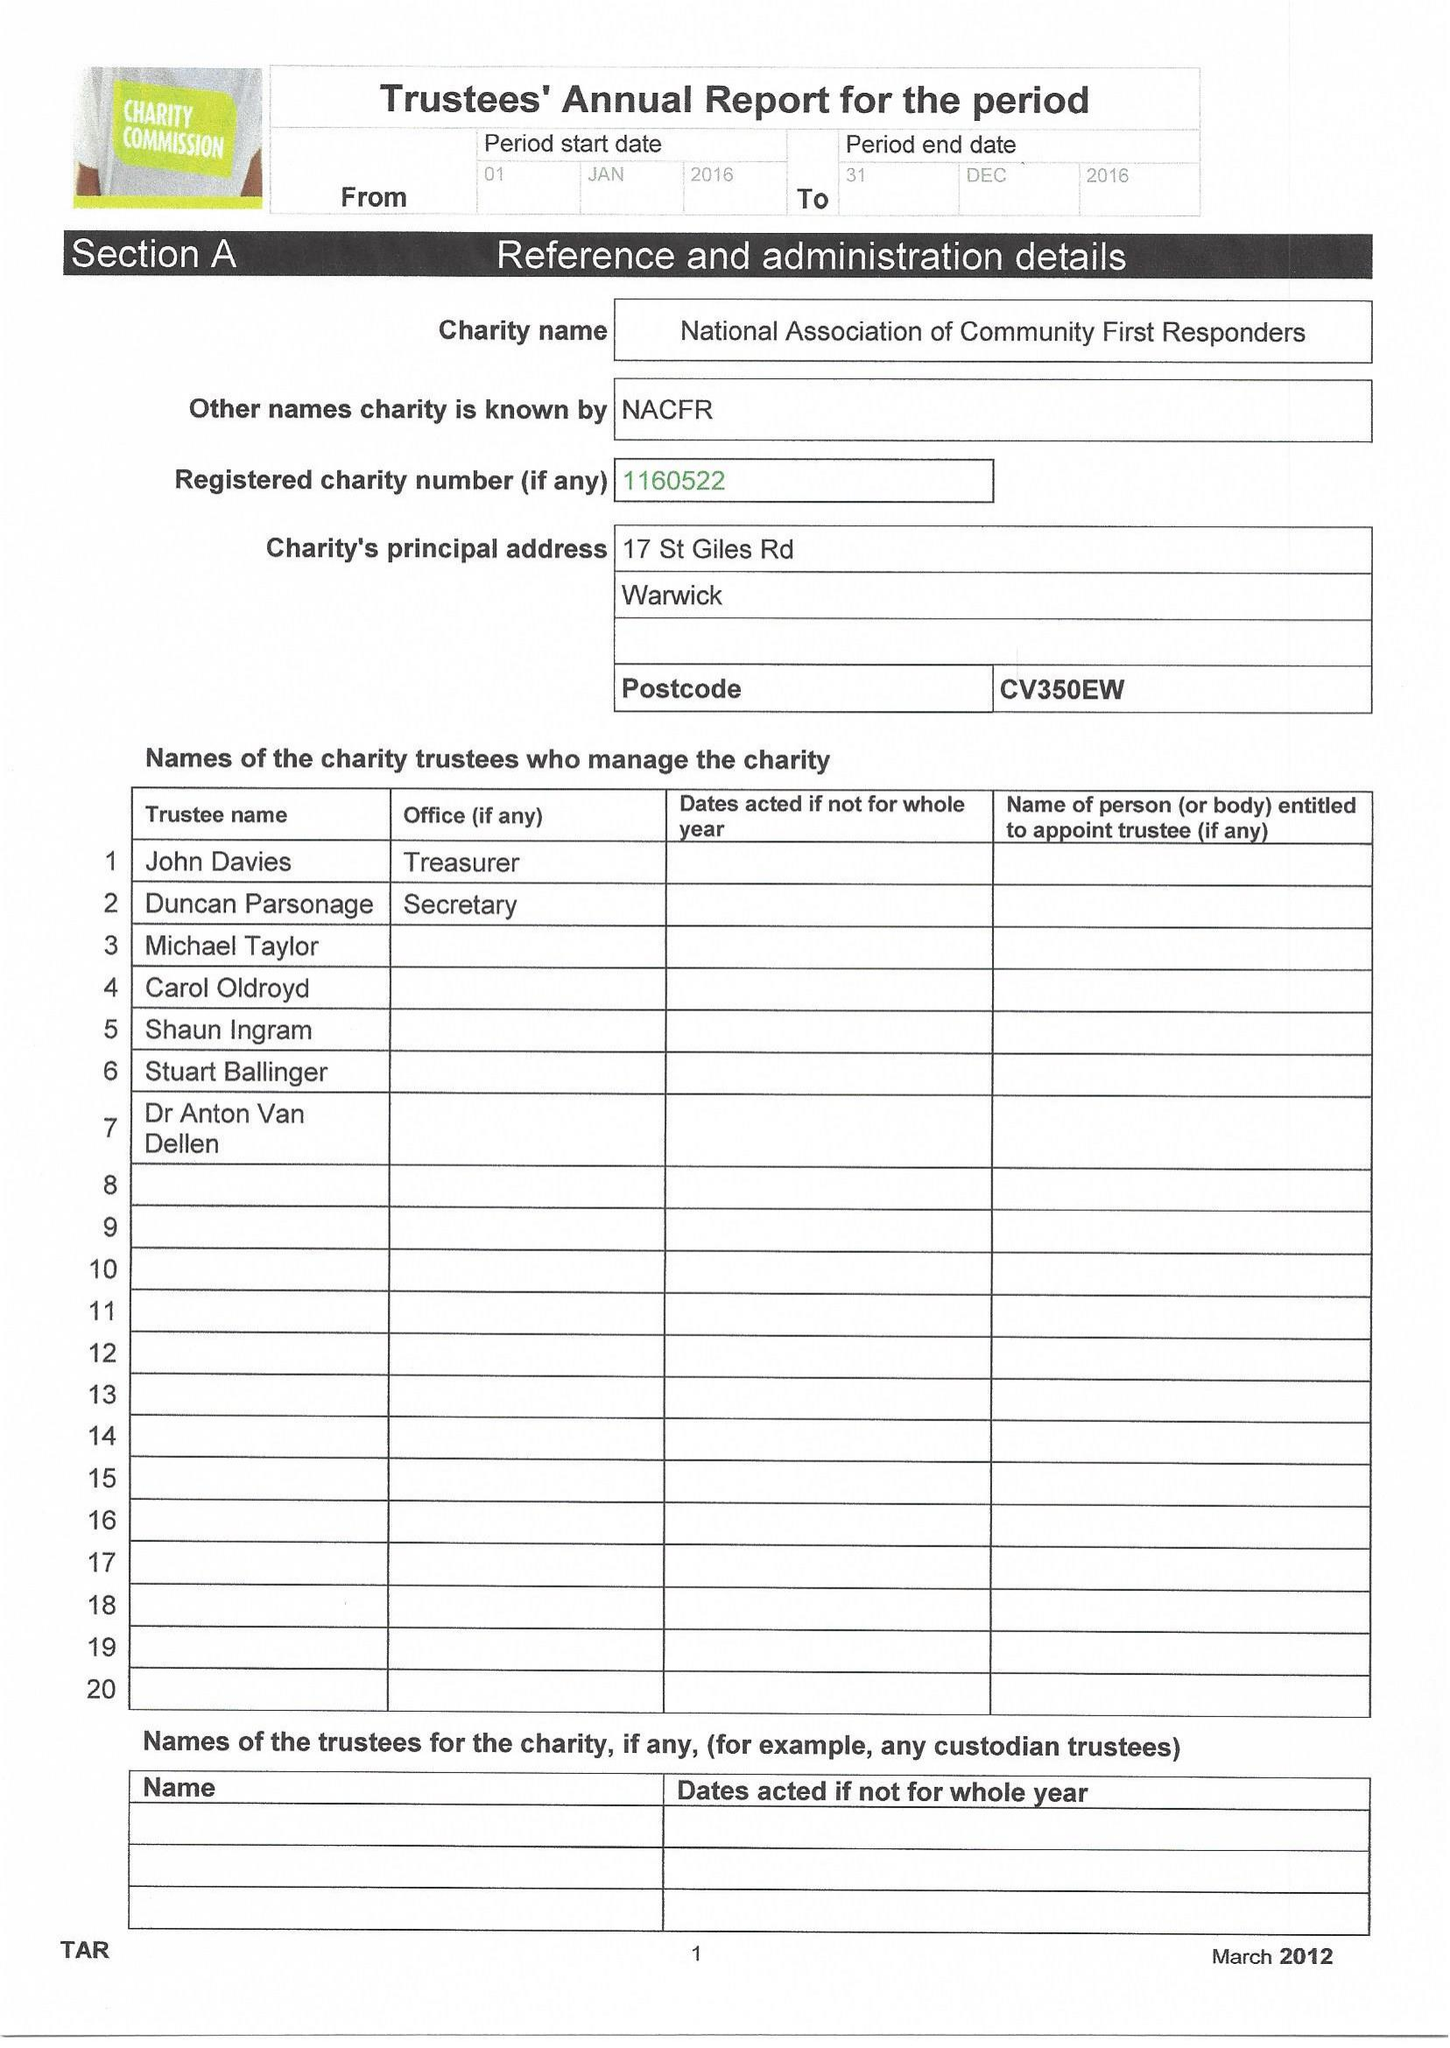What is the value for the address__post_town?
Answer the question using a single word or phrase. WARWICK 